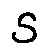<formula> <loc_0><loc_0><loc_500><loc_500>s</formula> 